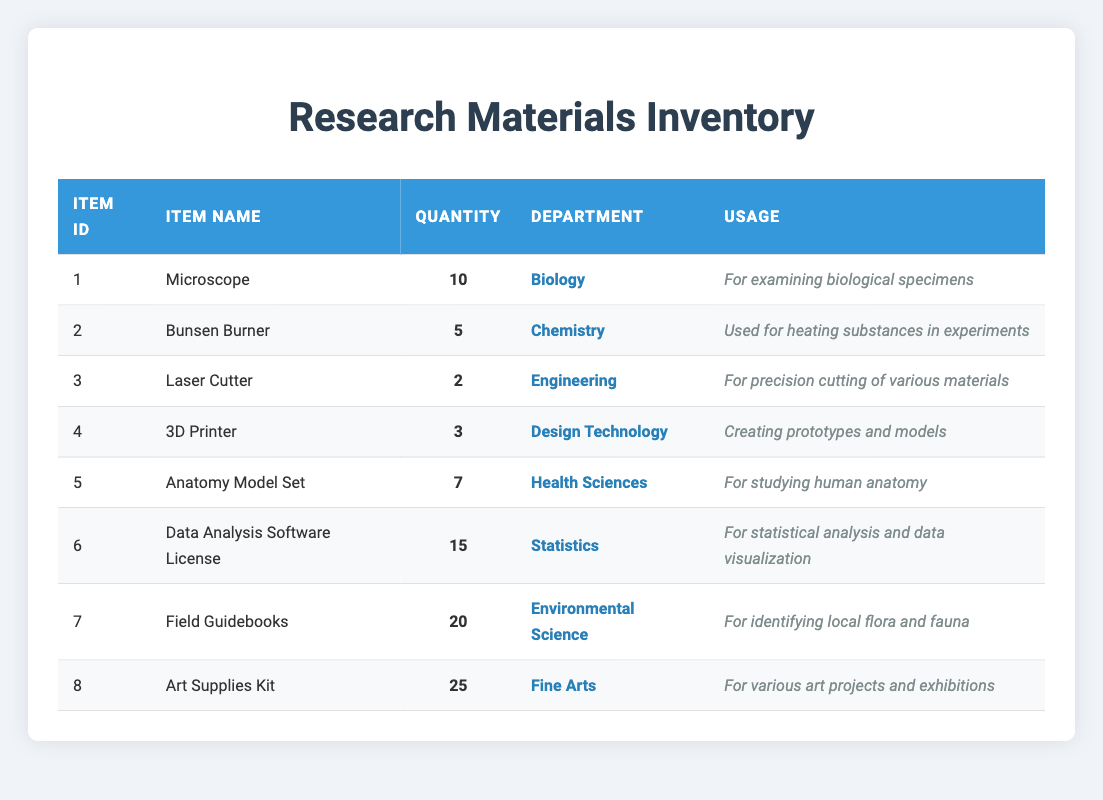What is the total quantity of microscopes available? The table lists that there are 10 microscopes under the "Quantity" column, specifically for the "Microscope" item in the "Biology" department. Therefore, the total quantity of microscopes is directly taken from the table.
Answer: 10 Which department has the highest number of items available? By examining the "Quantity" column, the "Art Supplies Kit" in the "Fine Arts" department shows the highest quantity with 25 items. Comparing it with other items, no other item exceeds this number.
Answer: Fine Arts Is there a field guidebook available for identifying local flora and fauna? The table includes an entry for "Field Guidebooks" with a "Usage" description stating they are specifically meant for identifying local flora and fauna. Thus, field guidebooks are indeed available for that purpose.
Answer: Yes What is the difference in the number of "3D Printers" and "Laser Cutters"? The quantity of "3D Printers" is 3 and the quantity of "Laser Cutters" is 2. To find the difference, subtract 2 from 3 which gives a difference of 1.
Answer: 1 How many items are available in the "Health Sciences" department? In the table, only the "Anatomy Model Set" listed under "Health Sciences" has a quantity of 7, and no other items belong to this department. Thus, the total is simply that one item.
Answer: 7 What percentage of the total inventory does the "Data Analysis Software License" represent? First, sum the quantities of all items: 10 + 5 + 2 + 3 + 7 + 15 + 20 + 25 = 87. The quantity of "Data Analysis Software License" is 15. To find the percentage, use the formula (15/87) * 100 which results in approximately 17.24%.
Answer: 17.24% Are there any supplies available specifically for heating substances? The "Bunsen Burner," which is listed in the Chemistry department, specifies in its usage that it is used for heating substances in experiments. Thus, it confirms the availability for that purpose.
Answer: Yes If the "Art Supplies Kit" doubles its quantity, what will be the new total? The current quantity of "Art Supplies Kit" is 25. If it doubles, the new total quantity will be 25 * 2 = 50. This reasoning is straightforward as it is a simple multiplication.
Answer: 50 What is the combined quantity of equipment available for the Biology and Chemistry departments? The table shows that the Biology department has 10 microscopes, and the Chemistry department has 5 Bunsen burners. Adding these two quantities gives 10 + 5 = 15.
Answer: 15 